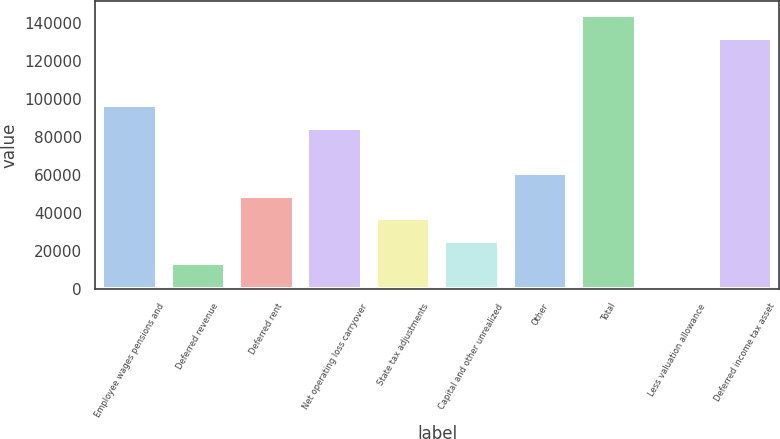<chart> <loc_0><loc_0><loc_500><loc_500><bar_chart><fcel>Employee wages pensions and<fcel>Deferred revenue<fcel>Deferred rent<fcel>Net operating loss carryover<fcel>State tax adjustments<fcel>Capital and other unrealized<fcel>Other<fcel>Total<fcel>Less valuation allowance<fcel>Deferred income tax asset<nl><fcel>96788.6<fcel>13511.7<fcel>49201.8<fcel>84891.9<fcel>37305.1<fcel>25408.4<fcel>61098.5<fcel>144375<fcel>1615<fcel>132479<nl></chart> 